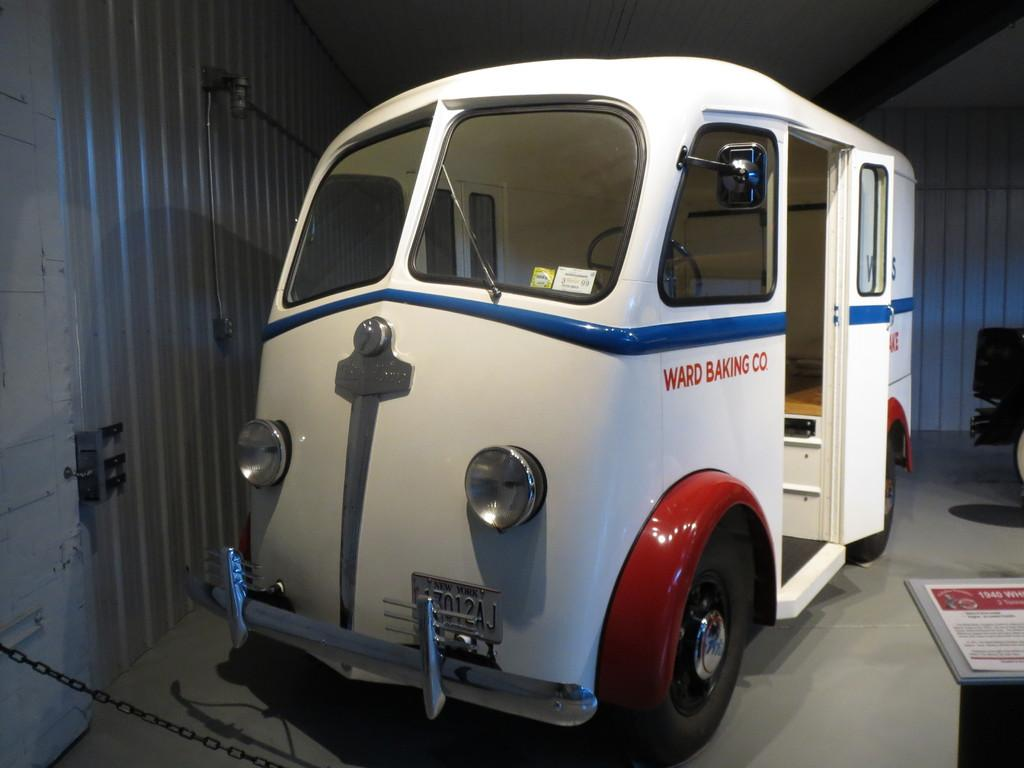What is the main subject of the image? There is a vehicle in the image. Where is the vehicle located? The vehicle is parked on the ground. What can be seen in the background of the image? There is a door and a chain in the background of the image. How many bubbles are floating around the vehicle in the image? There are no bubbles present in the image. 